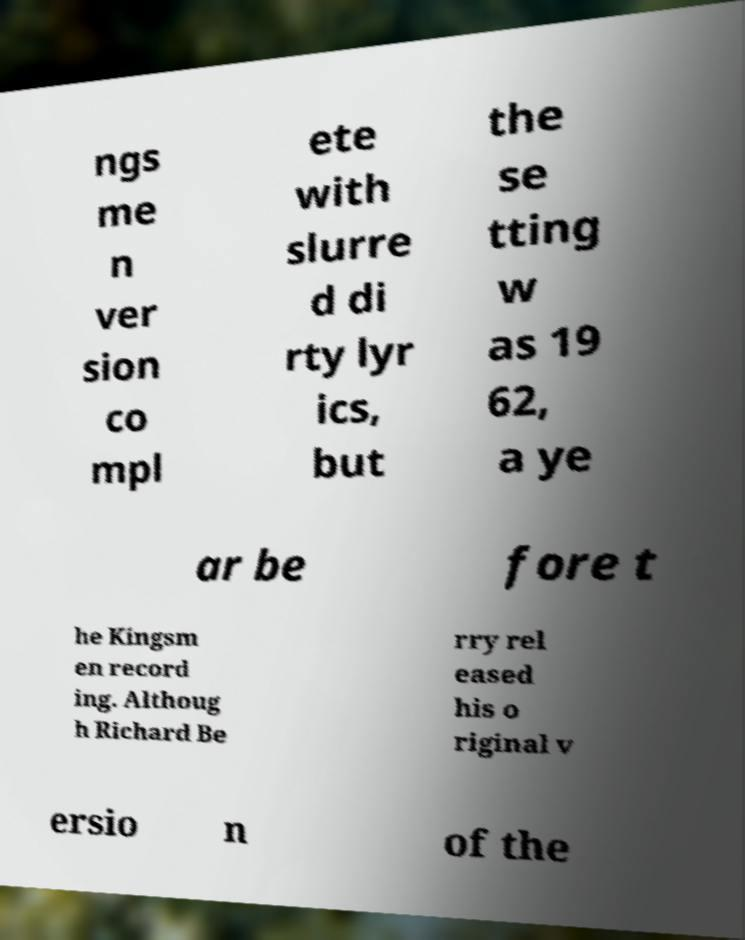For documentation purposes, I need the text within this image transcribed. Could you provide that? ngs me n ver sion co mpl ete with slurre d di rty lyr ics, but the se tting w as 19 62, a ye ar be fore t he Kingsm en record ing. Althoug h Richard Be rry rel eased his o riginal v ersio n of the 